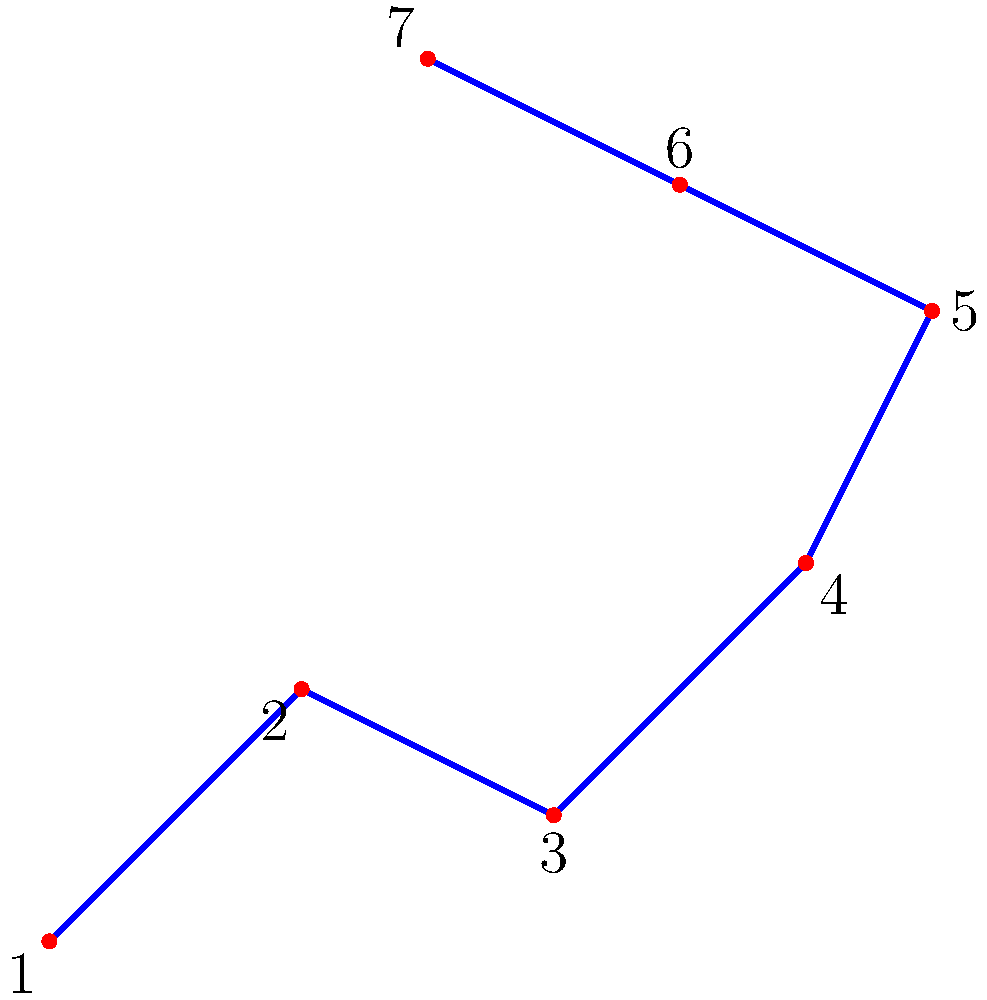Alright, ya radge, if ye were spottin' stars instead of trains, which two stars in the Big Dipper would ye use to find the North Star, assuming ye're as lost as Renton trying to get clean? Let's break this down, ya muppet:

1. The Big Dipper, or Ursa Major, is a prominent constellation visible in the Northern Hemisphere.
2. It's shaped like a big spoon or dipper, hence the name.
3. To find the North Star (Polaris), ye need to use the two stars at the front edge of the dipper's bowl.
4. In our diagram, these are stars labeled 6 and 7.
5. If ye draw an imaginary line from star 6 through star 7 and extend it about 5 times the distance between them, ye'll reach Polaris.
6. Polaris is always in the north, so it's dead useful for navigation when ye're lost in the scheme or trying to find yer way home after a mad night out.

So, like Spud trying to get to his job interview on time, ye want to focus on stars 6 and 7 to find yer way, ya radge.
Answer: Stars 6 and 7 